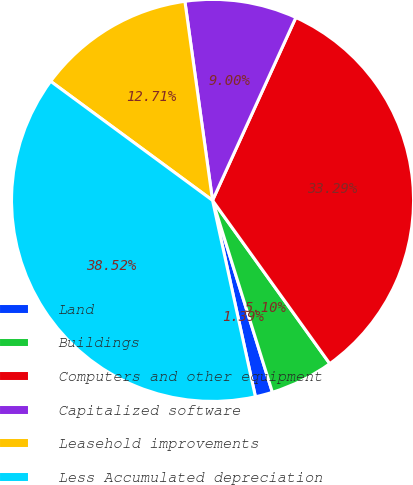Convert chart. <chart><loc_0><loc_0><loc_500><loc_500><pie_chart><fcel>Land<fcel>Buildings<fcel>Computers and other equipment<fcel>Capitalized software<fcel>Leasehold improvements<fcel>Less Accumulated depreciation<nl><fcel>1.39%<fcel>5.1%<fcel>33.29%<fcel>9.0%<fcel>12.71%<fcel>38.52%<nl></chart> 